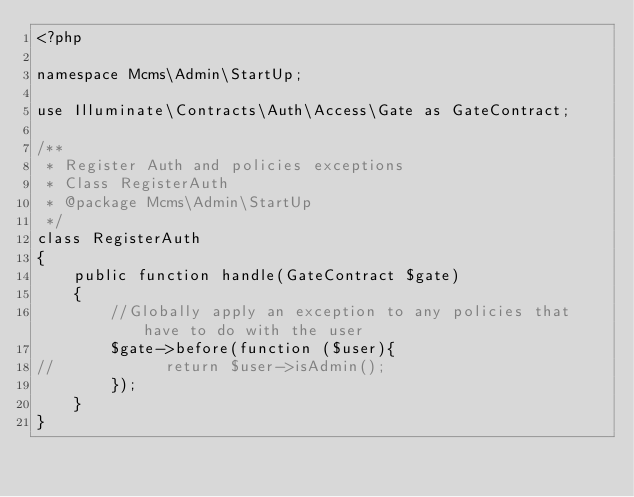Convert code to text. <code><loc_0><loc_0><loc_500><loc_500><_PHP_><?php

namespace Mcms\Admin\StartUp;

use Illuminate\Contracts\Auth\Access\Gate as GateContract;

/**
 * Register Auth and policies exceptions
 * Class RegisterAuth
 * @package Mcms\Admin\StartUp
 */
class RegisterAuth
{
    public function handle(GateContract $gate)
    {
        //Globally apply an exception to any policies that have to do with the user
        $gate->before(function ($user){
//            return $user->isAdmin();
        });
    }
}</code> 